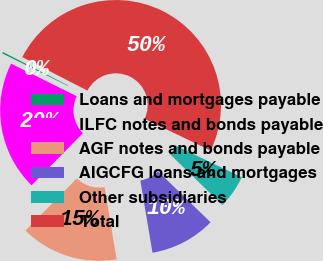Convert chart. <chart><loc_0><loc_0><loc_500><loc_500><pie_chart><fcel>Loans and mortgages payable<fcel>ILFC notes and bonds payable<fcel>AGF notes and bonds payable<fcel>AIGCFG loans and mortgages<fcel>Other subsidiaries<fcel>Total<nl><fcel>0.23%<fcel>19.95%<fcel>15.02%<fcel>10.09%<fcel>5.16%<fcel>49.54%<nl></chart> 